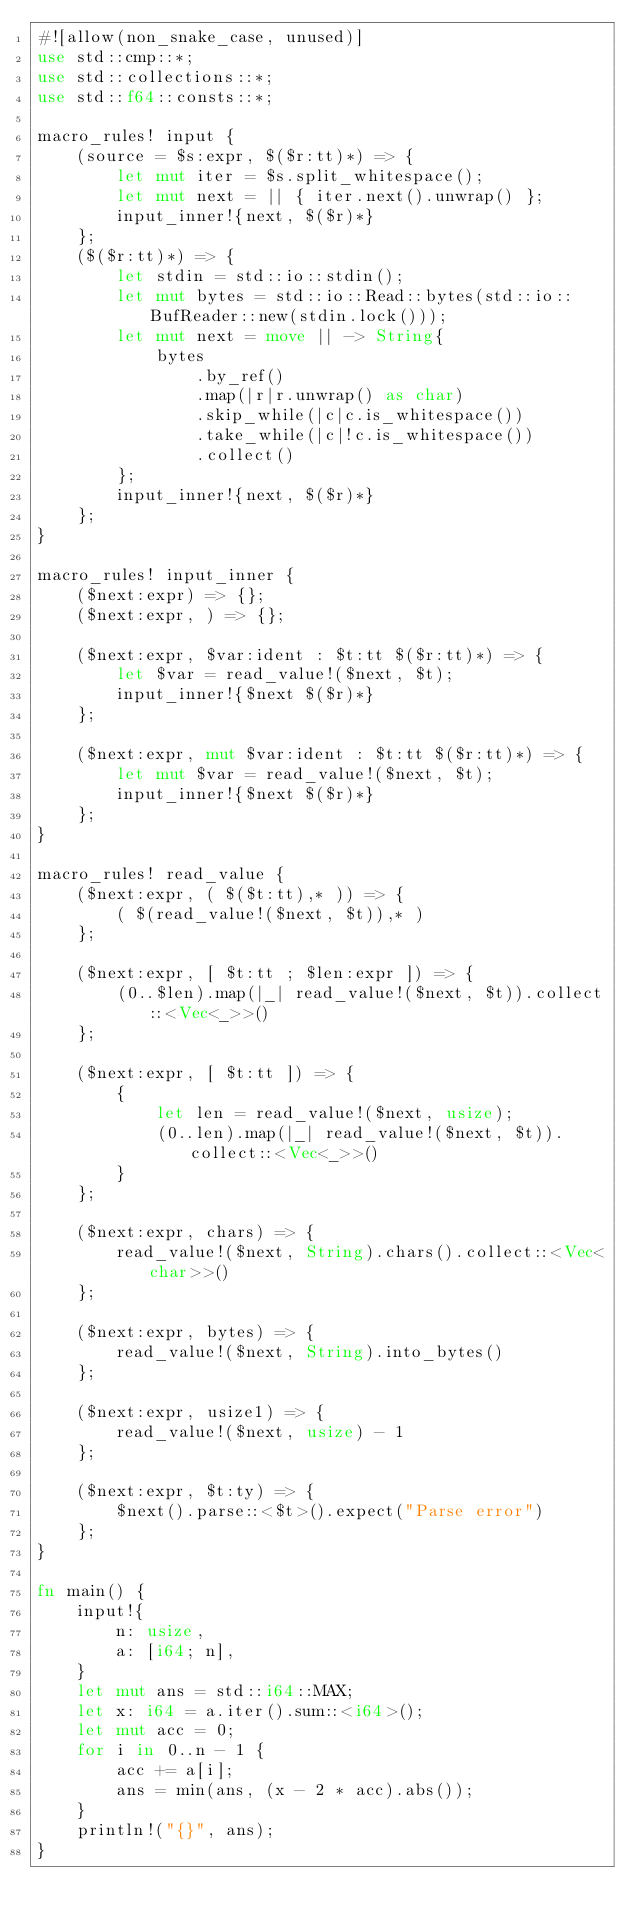Convert code to text. <code><loc_0><loc_0><loc_500><loc_500><_Rust_>#![allow(non_snake_case, unused)]
use std::cmp::*;
use std::collections::*;
use std::f64::consts::*;

macro_rules! input {
    (source = $s:expr, $($r:tt)*) => {
        let mut iter = $s.split_whitespace();
        let mut next = || { iter.next().unwrap() };
        input_inner!{next, $($r)*}
    };
    ($($r:tt)*) => {
        let stdin = std::io::stdin();
        let mut bytes = std::io::Read::bytes(std::io::BufReader::new(stdin.lock()));
        let mut next = move || -> String{
            bytes
                .by_ref()
                .map(|r|r.unwrap() as char)
                .skip_while(|c|c.is_whitespace())
                .take_while(|c|!c.is_whitespace())
                .collect()
        };
        input_inner!{next, $($r)*}
    };
}

macro_rules! input_inner {
    ($next:expr) => {};
    ($next:expr, ) => {};

    ($next:expr, $var:ident : $t:tt $($r:tt)*) => {
        let $var = read_value!($next, $t);
        input_inner!{$next $($r)*}
    };

    ($next:expr, mut $var:ident : $t:tt $($r:tt)*) => {
        let mut $var = read_value!($next, $t);
        input_inner!{$next $($r)*}
    };
}

macro_rules! read_value {
    ($next:expr, ( $($t:tt),* )) => {
        ( $(read_value!($next, $t)),* )
    };

    ($next:expr, [ $t:tt ; $len:expr ]) => {
        (0..$len).map(|_| read_value!($next, $t)).collect::<Vec<_>>()
    };

    ($next:expr, [ $t:tt ]) => {
        {
            let len = read_value!($next, usize);
            (0..len).map(|_| read_value!($next, $t)).collect::<Vec<_>>()
        }
    };

    ($next:expr, chars) => {
        read_value!($next, String).chars().collect::<Vec<char>>()
    };

    ($next:expr, bytes) => {
        read_value!($next, String).into_bytes()
    };

    ($next:expr, usize1) => {
        read_value!($next, usize) - 1
    };

    ($next:expr, $t:ty) => {
        $next().parse::<$t>().expect("Parse error")
    };
}

fn main() {
    input!{
        n: usize,
        a: [i64; n],
    }
    let mut ans = std::i64::MAX;
    let x: i64 = a.iter().sum::<i64>();
    let mut acc = 0;
    for i in 0..n - 1 {
        acc += a[i];
        ans = min(ans, (x - 2 * acc).abs());
    }
    println!("{}", ans);
}
</code> 